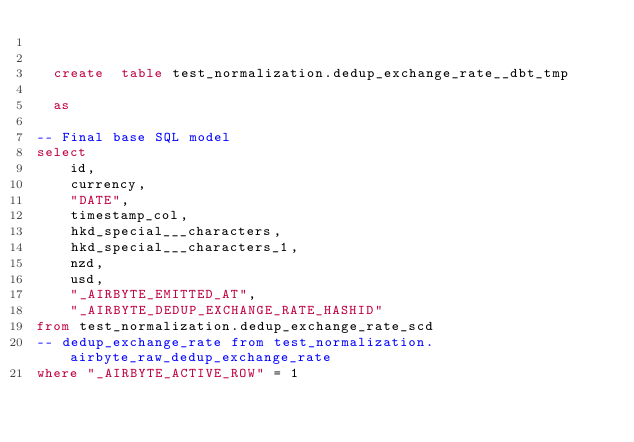<code> <loc_0><loc_0><loc_500><loc_500><_SQL_>

  create  table test_normalization.dedup_exchange_rate__dbt_tmp
  
  as
    
-- Final base SQL model
select
    id,
    currency,
    "DATE",
    timestamp_col,
    hkd_special___characters,
    hkd_special___characters_1,
    nzd,
    usd,
    "_AIRBYTE_EMITTED_AT",
    "_AIRBYTE_DEDUP_EXCHANGE_RATE_HASHID"
from test_normalization.dedup_exchange_rate_scd
-- dedup_exchange_rate from test_normalization.airbyte_raw_dedup_exchange_rate
where "_AIRBYTE_ACTIVE_ROW" = 1</code> 